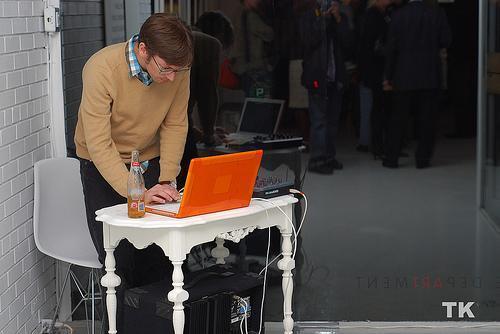How many bottles are in the picture?
Give a very brief answer. 1. 